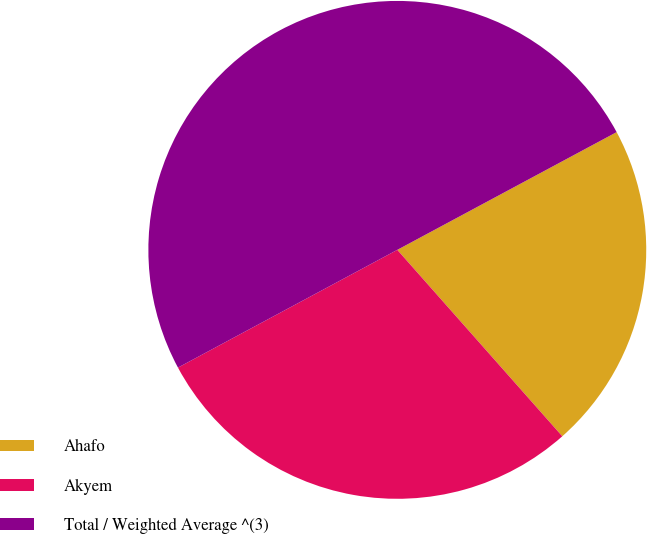Convert chart. <chart><loc_0><loc_0><loc_500><loc_500><pie_chart><fcel>Ahafo<fcel>Akyem<fcel>Total / Weighted Average ^(3)<nl><fcel>21.31%<fcel>28.69%<fcel>50.0%<nl></chart> 